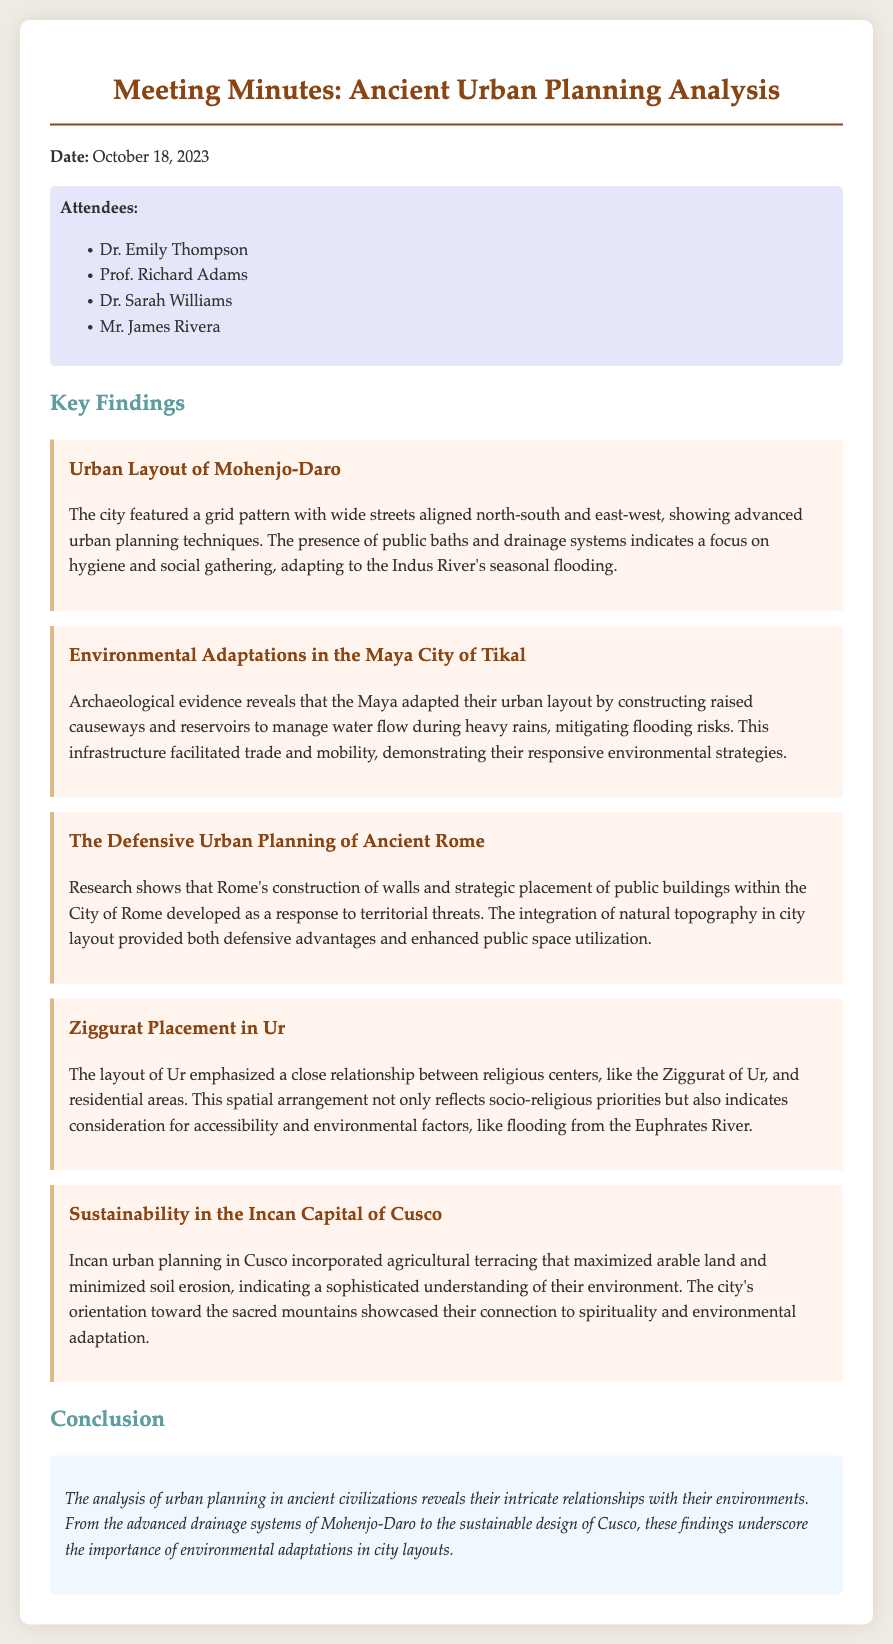What date was the meeting held? The date of the meeting is written at the beginning of the document.
Answer: October 18, 2023 Who is one of the attendees? The list of attendees is provided in the document, and one can be identified.
Answer: Dr. Emily Thompson What urban planning technique was used in Mohenjo-Daro? The document describes a specific urban planning technique used in Mohenjo-Daro.
Answer: Grid pattern What environmental adaptation was observed in Tikal? The document mentions a specific environmental adaptation that was utilized by the Maya in Tikal.
Answer: Raised causeways Which city emphasized the placement of religious centers? The document states which city's layout reflected a close relationship between religious centers and residential areas.
Answer: Ur How did the Incans maximize arable land? This question examines details on agricultural practices mentioned in the document.
Answer: Agricultural terracing What was a defensive strategy mentioned for Ancient Rome? The document highlights a specific strategy related to defense in Ancient Rome.
Answer: Construction of walls Which ancient civilization is mentioned for its sustainable design? The document references which civilization incorporated sustainability into urban planning.
Answer: Incan What did the drainage systems in Mohenjo-Daro indicate? This question requires connecting information regarding the purpose of drainage systems.
Answer: Focus on hygiene 